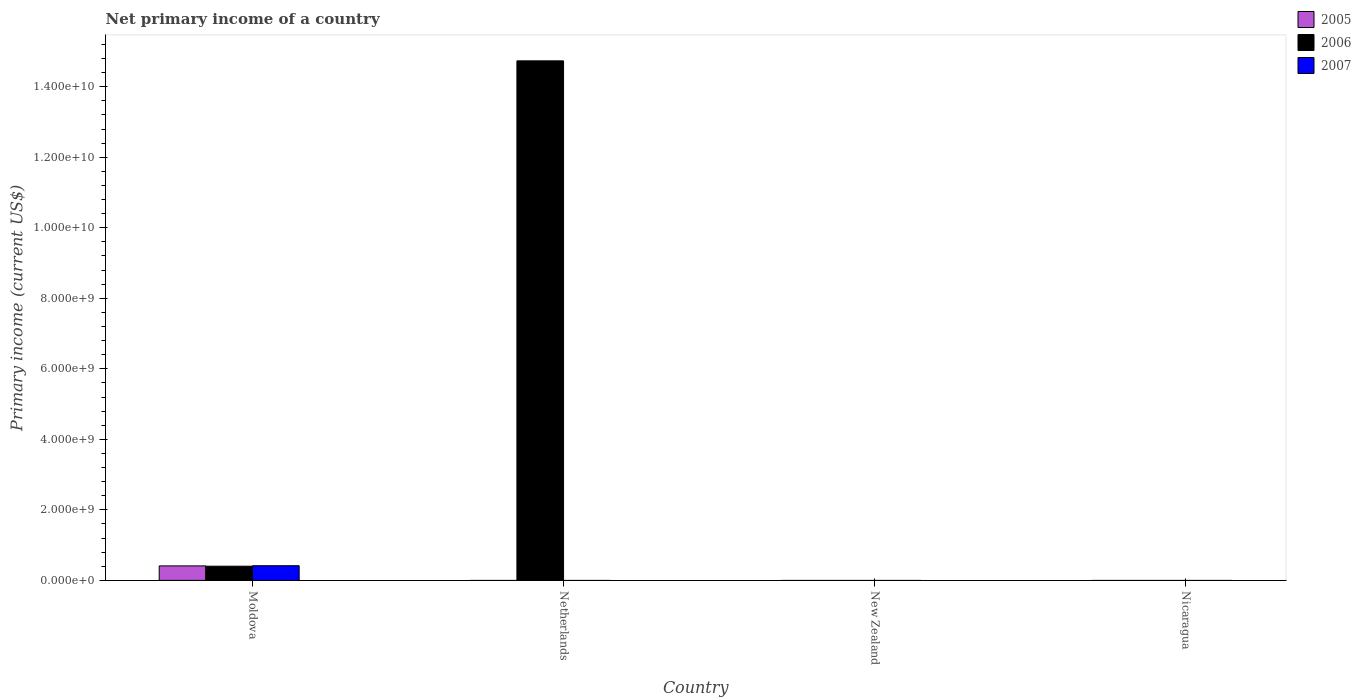How many different coloured bars are there?
Provide a succinct answer. 3. What is the label of the 4th group of bars from the left?
Ensure brevity in your answer.  Nicaragua. What is the primary income in 2006 in New Zealand?
Your response must be concise. 0. Across all countries, what is the maximum primary income in 2005?
Offer a very short reply. 4.11e+08. In which country was the primary income in 2007 maximum?
Provide a short and direct response. Moldova. What is the total primary income in 2005 in the graph?
Keep it short and to the point. 4.11e+08. What is the difference between the primary income in 2006 in Moldova and that in Netherlands?
Give a very brief answer. -1.43e+1. What is the difference between the primary income in 2005 in Moldova and the primary income in 2007 in Netherlands?
Offer a very short reply. 4.11e+08. What is the average primary income in 2005 per country?
Your response must be concise. 1.03e+08. What is the difference between the primary income of/in 2005 and primary income of/in 2006 in Moldova?
Ensure brevity in your answer.  8.36e+06. What is the difference between the highest and the lowest primary income in 2006?
Your response must be concise. 1.47e+1. How many bars are there?
Make the answer very short. 4. How many countries are there in the graph?
Your answer should be very brief. 4. Are the values on the major ticks of Y-axis written in scientific E-notation?
Your answer should be very brief. Yes. Does the graph contain any zero values?
Offer a terse response. Yes. Does the graph contain grids?
Offer a very short reply. No. What is the title of the graph?
Ensure brevity in your answer.  Net primary income of a country. Does "1969" appear as one of the legend labels in the graph?
Keep it short and to the point. No. What is the label or title of the Y-axis?
Offer a very short reply. Primary income (current US$). What is the Primary income (current US$) of 2005 in Moldova?
Offer a very short reply. 4.11e+08. What is the Primary income (current US$) of 2006 in Moldova?
Keep it short and to the point. 4.03e+08. What is the Primary income (current US$) in 2007 in Moldova?
Offer a terse response. 4.16e+08. What is the Primary income (current US$) of 2005 in Netherlands?
Your answer should be compact. 0. What is the Primary income (current US$) in 2006 in Netherlands?
Make the answer very short. 1.47e+1. What is the Primary income (current US$) of 2007 in Netherlands?
Your answer should be very brief. 0. What is the Primary income (current US$) in 2005 in New Zealand?
Your response must be concise. 0. What is the Primary income (current US$) of 2006 in New Zealand?
Your response must be concise. 0. What is the Primary income (current US$) in 2005 in Nicaragua?
Your response must be concise. 0. Across all countries, what is the maximum Primary income (current US$) of 2005?
Provide a succinct answer. 4.11e+08. Across all countries, what is the maximum Primary income (current US$) in 2006?
Keep it short and to the point. 1.47e+1. Across all countries, what is the maximum Primary income (current US$) in 2007?
Your answer should be very brief. 4.16e+08. Across all countries, what is the minimum Primary income (current US$) in 2005?
Your answer should be very brief. 0. Across all countries, what is the minimum Primary income (current US$) of 2006?
Ensure brevity in your answer.  0. What is the total Primary income (current US$) in 2005 in the graph?
Your answer should be very brief. 4.11e+08. What is the total Primary income (current US$) in 2006 in the graph?
Offer a very short reply. 1.51e+1. What is the total Primary income (current US$) of 2007 in the graph?
Your response must be concise. 4.16e+08. What is the difference between the Primary income (current US$) in 2006 in Moldova and that in Netherlands?
Provide a short and direct response. -1.43e+1. What is the difference between the Primary income (current US$) in 2005 in Moldova and the Primary income (current US$) in 2006 in Netherlands?
Offer a very short reply. -1.43e+1. What is the average Primary income (current US$) in 2005 per country?
Offer a very short reply. 1.03e+08. What is the average Primary income (current US$) in 2006 per country?
Provide a succinct answer. 3.78e+09. What is the average Primary income (current US$) in 2007 per country?
Provide a succinct answer. 1.04e+08. What is the difference between the Primary income (current US$) of 2005 and Primary income (current US$) of 2006 in Moldova?
Offer a very short reply. 8.36e+06. What is the difference between the Primary income (current US$) of 2005 and Primary income (current US$) of 2007 in Moldova?
Make the answer very short. -5.52e+06. What is the difference between the Primary income (current US$) of 2006 and Primary income (current US$) of 2007 in Moldova?
Your response must be concise. -1.39e+07. What is the ratio of the Primary income (current US$) of 2006 in Moldova to that in Netherlands?
Give a very brief answer. 0.03. What is the difference between the highest and the lowest Primary income (current US$) in 2005?
Ensure brevity in your answer.  4.11e+08. What is the difference between the highest and the lowest Primary income (current US$) of 2006?
Offer a very short reply. 1.47e+1. What is the difference between the highest and the lowest Primary income (current US$) of 2007?
Offer a very short reply. 4.16e+08. 